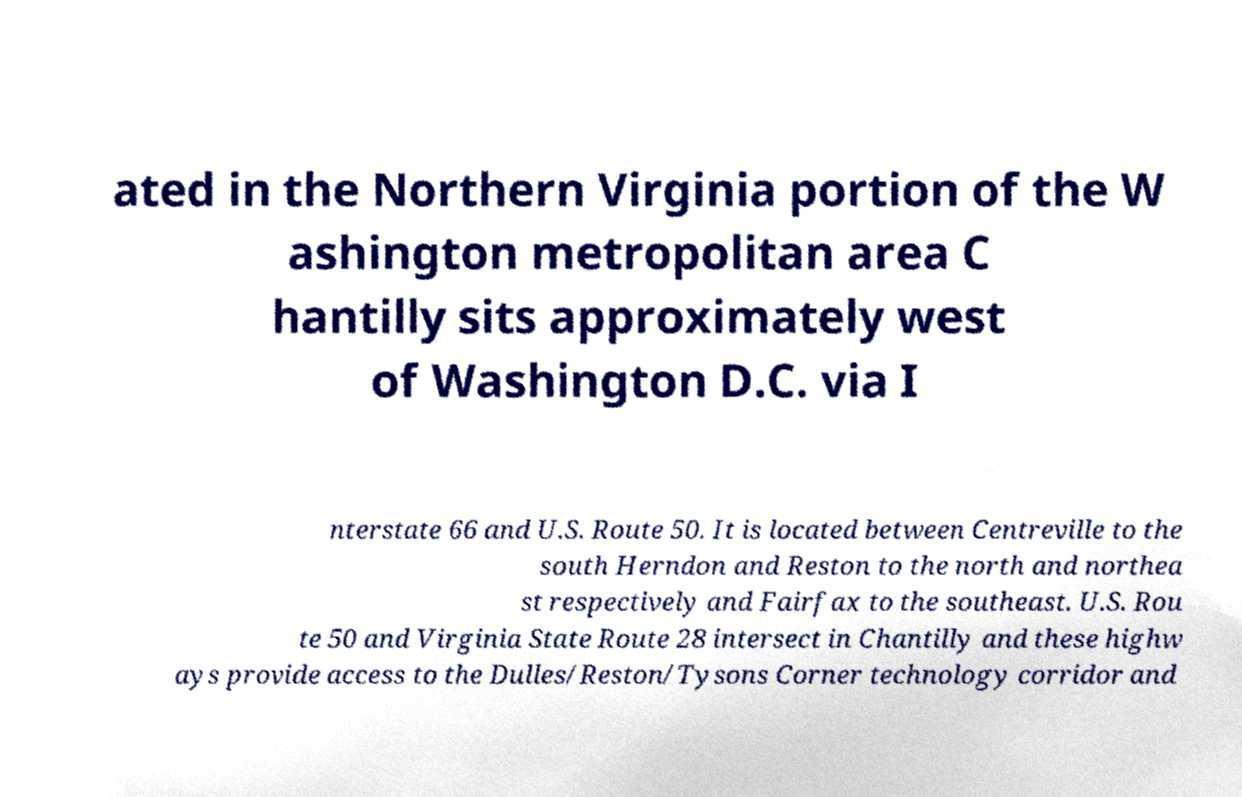Please read and relay the text visible in this image. What does it say? ated in the Northern Virginia portion of the W ashington metropolitan area C hantilly sits approximately west of Washington D.C. via I nterstate 66 and U.S. Route 50. It is located between Centreville to the south Herndon and Reston to the north and northea st respectively and Fairfax to the southeast. U.S. Rou te 50 and Virginia State Route 28 intersect in Chantilly and these highw ays provide access to the Dulles/Reston/Tysons Corner technology corridor and 